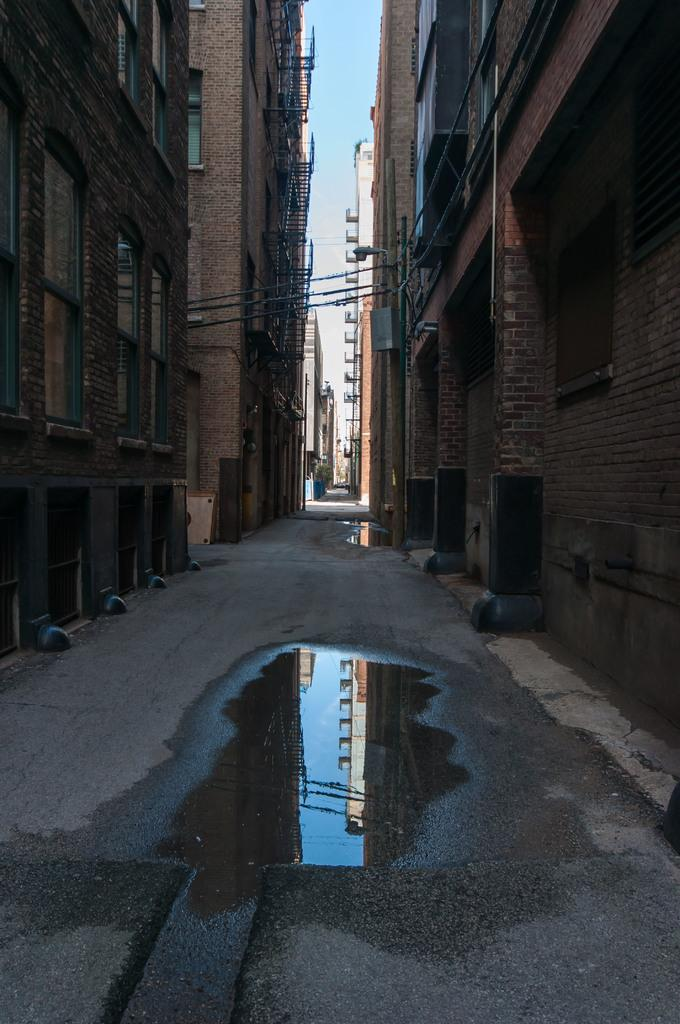What is present on the road in the image? There is water on the road in the image. What can be seen on both sides of the road? There are buildings on both sides of the road. What feature do the buildings have? The buildings have windows. What is visible in the background of the image? There are buildings in the background. What is the color of the sky in the image? The sky is blue in the image, and there are clouds visible. What rhythm is being played by the clouds in the image? There is no rhythm being played by the clouds in the image; they are simply visible in the blue sky. What statement can be made about the clouds in the image? The clouds are visible in the blue sky in the image. What change occurs in the image when the clouds move? There is no change in the image when the clouds move, as the image is a still representation. 